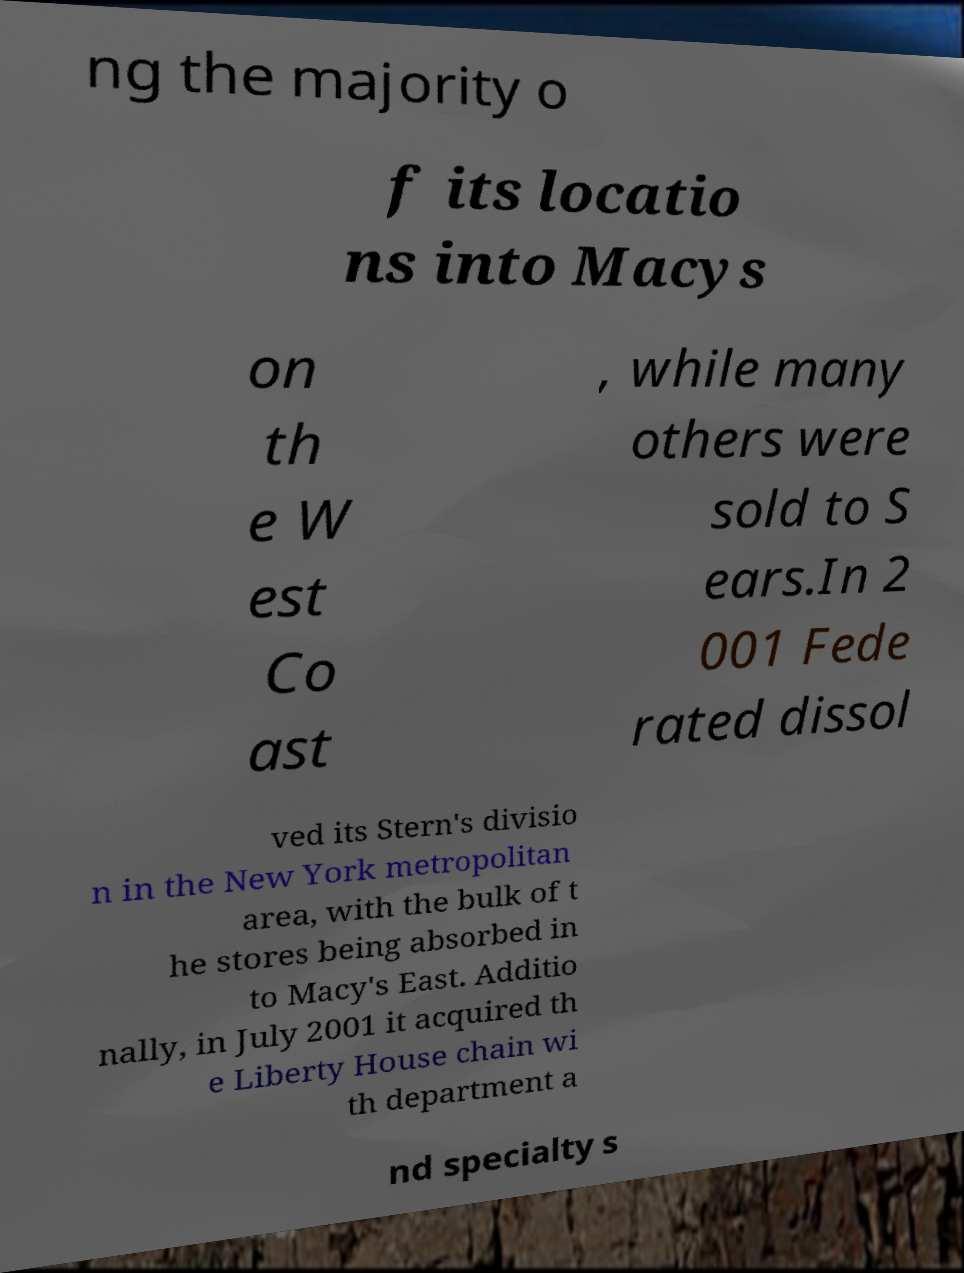Can you read and provide the text displayed in the image?This photo seems to have some interesting text. Can you extract and type it out for me? ng the majority o f its locatio ns into Macys on th e W est Co ast , while many others were sold to S ears.In 2 001 Fede rated dissol ved its Stern's divisio n in the New York metropolitan area, with the bulk of t he stores being absorbed in to Macy's East. Additio nally, in July 2001 it acquired th e Liberty House chain wi th department a nd specialty s 